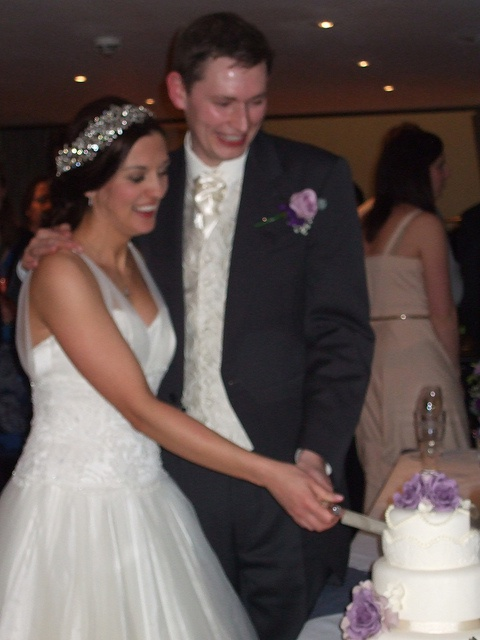Describe the objects in this image and their specific colors. I can see people in black, lightgray, brown, and darkgray tones, people in black, darkgray, brown, and gray tones, people in black, gray, maroon, and brown tones, cake in black, lightgray, darkgray, gray, and purple tones, and dining table in black and gray tones in this image. 